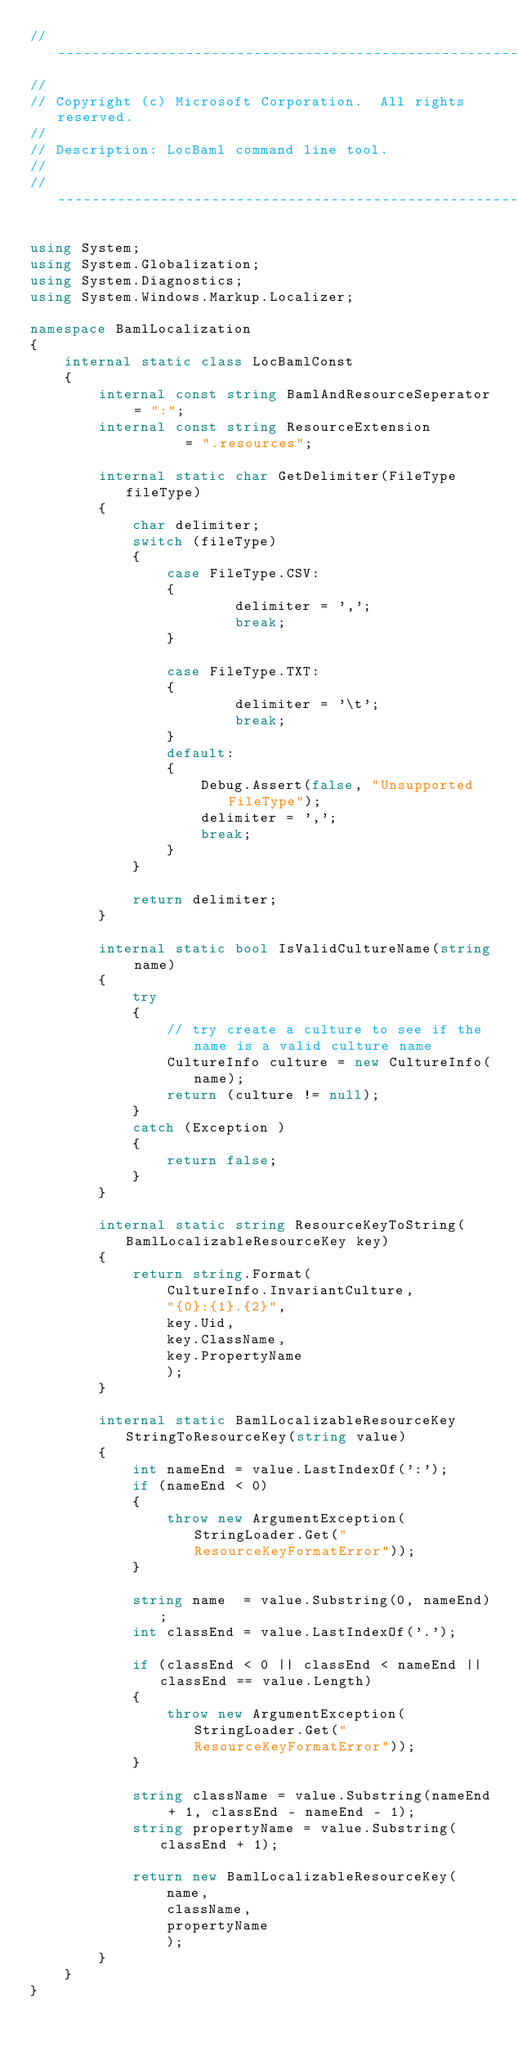<code> <loc_0><loc_0><loc_500><loc_500><_C#_>//---------------------------------------------------------------------------
//
// Copyright (c) Microsoft Corporation.  All rights reserved.
// 
// Description: LocBaml command line tool. 
//
//---------------------------------------------------------------------------

using System;
using System.Globalization;
using System.Diagnostics;
using System.Windows.Markup.Localizer;

namespace BamlLocalization
{
    internal static class LocBamlConst
    {
        internal const string BamlAndResourceSeperator = ":";
        internal const string ResourceExtension        = ".resources";

        internal static char GetDelimiter(FileType fileType)
        {
            char delimiter;
            switch (fileType)
            {
                case FileType.CSV:
                {
                        delimiter = ',';
                        break;
                }

                case FileType.TXT:
                {
                        delimiter = '\t';
                        break;
                }
                default:
                {
                    Debug.Assert(false, "Unsupported FileType");
                    delimiter = ','; 
                    break;
                }
            }
            
            return delimiter;
        }

        internal static bool IsValidCultureName(string name)
        {
            try 
            {
                // try create a culture to see if the name is a valid culture name
                CultureInfo culture = new CultureInfo(name);
                return (culture != null);
            }
            catch (Exception )
            {
                return false;
            }
        }

        internal static string ResourceKeyToString(BamlLocalizableResourceKey key)
        {
            return string.Format(
                CultureInfo.InvariantCulture, 
                "{0}:{1}.{2}", 
                key.Uid, 
                key.ClassName, 
                key.PropertyName
                );
        }

        internal static BamlLocalizableResourceKey StringToResourceKey(string value)
        {
            int nameEnd = value.LastIndexOf(':');
            if (nameEnd < 0)
            {
                throw new ArgumentException(StringLoader.Get("ResourceKeyFormatError"));
            }

            string name  = value.Substring(0, nameEnd);
            int classEnd = value.LastIndexOf('.');
            
            if (classEnd < 0 || classEnd < nameEnd || classEnd == value.Length)
            {
                throw new ArgumentException(StringLoader.Get("ResourceKeyFormatError"));
            }

            string className = value.Substring(nameEnd + 1, classEnd - nameEnd - 1);
            string propertyName = value.Substring(classEnd + 1);

            return new BamlLocalizableResourceKey(
                name,
                className,
                propertyName
                );            
        }
    }    
}
</code> 